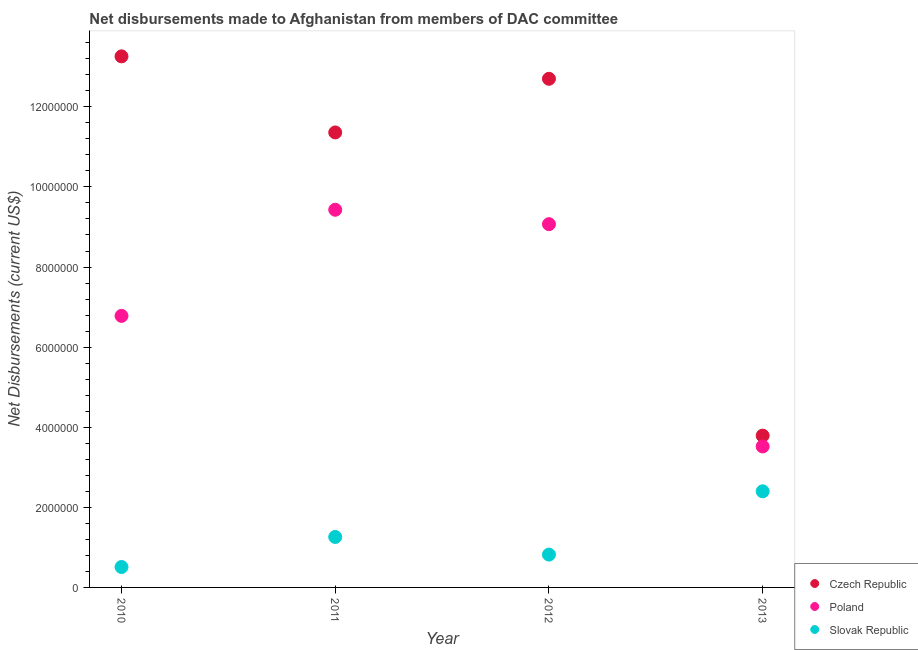What is the net disbursements made by slovak republic in 2012?
Your response must be concise. 8.20e+05. Across all years, what is the maximum net disbursements made by slovak republic?
Make the answer very short. 2.40e+06. Across all years, what is the minimum net disbursements made by czech republic?
Offer a terse response. 3.79e+06. In which year was the net disbursements made by czech republic maximum?
Provide a short and direct response. 2010. What is the total net disbursements made by czech republic in the graph?
Offer a very short reply. 4.11e+07. What is the difference between the net disbursements made by czech republic in 2010 and that in 2012?
Your response must be concise. 5.60e+05. What is the difference between the net disbursements made by poland in 2010 and the net disbursements made by czech republic in 2012?
Provide a succinct answer. -5.92e+06. What is the average net disbursements made by czech republic per year?
Your answer should be compact. 1.03e+07. In the year 2010, what is the difference between the net disbursements made by slovak republic and net disbursements made by czech republic?
Your answer should be very brief. -1.28e+07. What is the ratio of the net disbursements made by czech republic in 2012 to that in 2013?
Your answer should be very brief. 3.35. Is the difference between the net disbursements made by poland in 2010 and 2013 greater than the difference between the net disbursements made by slovak republic in 2010 and 2013?
Make the answer very short. Yes. What is the difference between the highest and the second highest net disbursements made by slovak republic?
Provide a succinct answer. 1.14e+06. What is the difference between the highest and the lowest net disbursements made by czech republic?
Your answer should be very brief. 9.47e+06. Is the net disbursements made by poland strictly less than the net disbursements made by slovak republic over the years?
Offer a very short reply. No. How many dotlines are there?
Make the answer very short. 3. How many years are there in the graph?
Offer a very short reply. 4. What is the difference between two consecutive major ticks on the Y-axis?
Give a very brief answer. 2.00e+06. Does the graph contain any zero values?
Give a very brief answer. No. Does the graph contain grids?
Make the answer very short. No. How many legend labels are there?
Make the answer very short. 3. What is the title of the graph?
Ensure brevity in your answer.  Net disbursements made to Afghanistan from members of DAC committee. Does "Interest" appear as one of the legend labels in the graph?
Keep it short and to the point. No. What is the label or title of the Y-axis?
Keep it short and to the point. Net Disbursements (current US$). What is the Net Disbursements (current US$) in Czech Republic in 2010?
Offer a terse response. 1.33e+07. What is the Net Disbursements (current US$) in Poland in 2010?
Offer a very short reply. 6.78e+06. What is the Net Disbursements (current US$) in Slovak Republic in 2010?
Your answer should be very brief. 5.10e+05. What is the Net Disbursements (current US$) in Czech Republic in 2011?
Provide a short and direct response. 1.14e+07. What is the Net Disbursements (current US$) in Poland in 2011?
Make the answer very short. 9.43e+06. What is the Net Disbursements (current US$) in Slovak Republic in 2011?
Keep it short and to the point. 1.26e+06. What is the Net Disbursements (current US$) in Czech Republic in 2012?
Your answer should be very brief. 1.27e+07. What is the Net Disbursements (current US$) of Poland in 2012?
Provide a short and direct response. 9.07e+06. What is the Net Disbursements (current US$) in Slovak Republic in 2012?
Your answer should be compact. 8.20e+05. What is the Net Disbursements (current US$) in Czech Republic in 2013?
Provide a short and direct response. 3.79e+06. What is the Net Disbursements (current US$) of Poland in 2013?
Offer a terse response. 3.52e+06. What is the Net Disbursements (current US$) in Slovak Republic in 2013?
Your response must be concise. 2.40e+06. Across all years, what is the maximum Net Disbursements (current US$) of Czech Republic?
Keep it short and to the point. 1.33e+07. Across all years, what is the maximum Net Disbursements (current US$) in Poland?
Ensure brevity in your answer.  9.43e+06. Across all years, what is the maximum Net Disbursements (current US$) of Slovak Republic?
Keep it short and to the point. 2.40e+06. Across all years, what is the minimum Net Disbursements (current US$) of Czech Republic?
Your response must be concise. 3.79e+06. Across all years, what is the minimum Net Disbursements (current US$) of Poland?
Offer a very short reply. 3.52e+06. Across all years, what is the minimum Net Disbursements (current US$) in Slovak Republic?
Ensure brevity in your answer.  5.10e+05. What is the total Net Disbursements (current US$) in Czech Republic in the graph?
Ensure brevity in your answer.  4.11e+07. What is the total Net Disbursements (current US$) in Poland in the graph?
Provide a succinct answer. 2.88e+07. What is the total Net Disbursements (current US$) in Slovak Republic in the graph?
Ensure brevity in your answer.  4.99e+06. What is the difference between the Net Disbursements (current US$) in Czech Republic in 2010 and that in 2011?
Give a very brief answer. 1.90e+06. What is the difference between the Net Disbursements (current US$) of Poland in 2010 and that in 2011?
Your answer should be compact. -2.65e+06. What is the difference between the Net Disbursements (current US$) in Slovak Republic in 2010 and that in 2011?
Offer a very short reply. -7.50e+05. What is the difference between the Net Disbursements (current US$) in Czech Republic in 2010 and that in 2012?
Keep it short and to the point. 5.60e+05. What is the difference between the Net Disbursements (current US$) in Poland in 2010 and that in 2012?
Keep it short and to the point. -2.29e+06. What is the difference between the Net Disbursements (current US$) of Slovak Republic in 2010 and that in 2012?
Provide a succinct answer. -3.10e+05. What is the difference between the Net Disbursements (current US$) of Czech Republic in 2010 and that in 2013?
Give a very brief answer. 9.47e+06. What is the difference between the Net Disbursements (current US$) of Poland in 2010 and that in 2013?
Your response must be concise. 3.26e+06. What is the difference between the Net Disbursements (current US$) of Slovak Republic in 2010 and that in 2013?
Your response must be concise. -1.89e+06. What is the difference between the Net Disbursements (current US$) in Czech Republic in 2011 and that in 2012?
Give a very brief answer. -1.34e+06. What is the difference between the Net Disbursements (current US$) in Slovak Republic in 2011 and that in 2012?
Offer a terse response. 4.40e+05. What is the difference between the Net Disbursements (current US$) of Czech Republic in 2011 and that in 2013?
Your answer should be very brief. 7.57e+06. What is the difference between the Net Disbursements (current US$) of Poland in 2011 and that in 2013?
Your answer should be very brief. 5.91e+06. What is the difference between the Net Disbursements (current US$) of Slovak Republic in 2011 and that in 2013?
Give a very brief answer. -1.14e+06. What is the difference between the Net Disbursements (current US$) of Czech Republic in 2012 and that in 2013?
Give a very brief answer. 8.91e+06. What is the difference between the Net Disbursements (current US$) in Poland in 2012 and that in 2013?
Your answer should be compact. 5.55e+06. What is the difference between the Net Disbursements (current US$) of Slovak Republic in 2012 and that in 2013?
Ensure brevity in your answer.  -1.58e+06. What is the difference between the Net Disbursements (current US$) in Czech Republic in 2010 and the Net Disbursements (current US$) in Poland in 2011?
Provide a short and direct response. 3.83e+06. What is the difference between the Net Disbursements (current US$) in Poland in 2010 and the Net Disbursements (current US$) in Slovak Republic in 2011?
Ensure brevity in your answer.  5.52e+06. What is the difference between the Net Disbursements (current US$) of Czech Republic in 2010 and the Net Disbursements (current US$) of Poland in 2012?
Provide a short and direct response. 4.19e+06. What is the difference between the Net Disbursements (current US$) in Czech Republic in 2010 and the Net Disbursements (current US$) in Slovak Republic in 2012?
Your response must be concise. 1.24e+07. What is the difference between the Net Disbursements (current US$) of Poland in 2010 and the Net Disbursements (current US$) of Slovak Republic in 2012?
Offer a very short reply. 5.96e+06. What is the difference between the Net Disbursements (current US$) in Czech Republic in 2010 and the Net Disbursements (current US$) in Poland in 2013?
Your answer should be very brief. 9.74e+06. What is the difference between the Net Disbursements (current US$) in Czech Republic in 2010 and the Net Disbursements (current US$) in Slovak Republic in 2013?
Offer a very short reply. 1.09e+07. What is the difference between the Net Disbursements (current US$) in Poland in 2010 and the Net Disbursements (current US$) in Slovak Republic in 2013?
Give a very brief answer. 4.38e+06. What is the difference between the Net Disbursements (current US$) in Czech Republic in 2011 and the Net Disbursements (current US$) in Poland in 2012?
Ensure brevity in your answer.  2.29e+06. What is the difference between the Net Disbursements (current US$) of Czech Republic in 2011 and the Net Disbursements (current US$) of Slovak Republic in 2012?
Offer a very short reply. 1.05e+07. What is the difference between the Net Disbursements (current US$) of Poland in 2011 and the Net Disbursements (current US$) of Slovak Republic in 2012?
Your answer should be compact. 8.61e+06. What is the difference between the Net Disbursements (current US$) of Czech Republic in 2011 and the Net Disbursements (current US$) of Poland in 2013?
Ensure brevity in your answer.  7.84e+06. What is the difference between the Net Disbursements (current US$) of Czech Republic in 2011 and the Net Disbursements (current US$) of Slovak Republic in 2013?
Offer a very short reply. 8.96e+06. What is the difference between the Net Disbursements (current US$) in Poland in 2011 and the Net Disbursements (current US$) in Slovak Republic in 2013?
Offer a very short reply. 7.03e+06. What is the difference between the Net Disbursements (current US$) in Czech Republic in 2012 and the Net Disbursements (current US$) in Poland in 2013?
Your answer should be very brief. 9.18e+06. What is the difference between the Net Disbursements (current US$) in Czech Republic in 2012 and the Net Disbursements (current US$) in Slovak Republic in 2013?
Keep it short and to the point. 1.03e+07. What is the difference between the Net Disbursements (current US$) of Poland in 2012 and the Net Disbursements (current US$) of Slovak Republic in 2013?
Give a very brief answer. 6.67e+06. What is the average Net Disbursements (current US$) in Czech Republic per year?
Keep it short and to the point. 1.03e+07. What is the average Net Disbursements (current US$) of Poland per year?
Make the answer very short. 7.20e+06. What is the average Net Disbursements (current US$) of Slovak Republic per year?
Give a very brief answer. 1.25e+06. In the year 2010, what is the difference between the Net Disbursements (current US$) in Czech Republic and Net Disbursements (current US$) in Poland?
Your response must be concise. 6.48e+06. In the year 2010, what is the difference between the Net Disbursements (current US$) of Czech Republic and Net Disbursements (current US$) of Slovak Republic?
Give a very brief answer. 1.28e+07. In the year 2010, what is the difference between the Net Disbursements (current US$) of Poland and Net Disbursements (current US$) of Slovak Republic?
Provide a succinct answer. 6.27e+06. In the year 2011, what is the difference between the Net Disbursements (current US$) in Czech Republic and Net Disbursements (current US$) in Poland?
Make the answer very short. 1.93e+06. In the year 2011, what is the difference between the Net Disbursements (current US$) in Czech Republic and Net Disbursements (current US$) in Slovak Republic?
Your answer should be very brief. 1.01e+07. In the year 2011, what is the difference between the Net Disbursements (current US$) in Poland and Net Disbursements (current US$) in Slovak Republic?
Your response must be concise. 8.17e+06. In the year 2012, what is the difference between the Net Disbursements (current US$) of Czech Republic and Net Disbursements (current US$) of Poland?
Your answer should be compact. 3.63e+06. In the year 2012, what is the difference between the Net Disbursements (current US$) of Czech Republic and Net Disbursements (current US$) of Slovak Republic?
Your response must be concise. 1.19e+07. In the year 2012, what is the difference between the Net Disbursements (current US$) in Poland and Net Disbursements (current US$) in Slovak Republic?
Keep it short and to the point. 8.25e+06. In the year 2013, what is the difference between the Net Disbursements (current US$) in Czech Republic and Net Disbursements (current US$) in Poland?
Provide a short and direct response. 2.70e+05. In the year 2013, what is the difference between the Net Disbursements (current US$) of Czech Republic and Net Disbursements (current US$) of Slovak Republic?
Provide a succinct answer. 1.39e+06. In the year 2013, what is the difference between the Net Disbursements (current US$) of Poland and Net Disbursements (current US$) of Slovak Republic?
Your answer should be very brief. 1.12e+06. What is the ratio of the Net Disbursements (current US$) of Czech Republic in 2010 to that in 2011?
Keep it short and to the point. 1.17. What is the ratio of the Net Disbursements (current US$) of Poland in 2010 to that in 2011?
Provide a succinct answer. 0.72. What is the ratio of the Net Disbursements (current US$) of Slovak Republic in 2010 to that in 2011?
Provide a short and direct response. 0.4. What is the ratio of the Net Disbursements (current US$) of Czech Republic in 2010 to that in 2012?
Provide a short and direct response. 1.04. What is the ratio of the Net Disbursements (current US$) of Poland in 2010 to that in 2012?
Provide a succinct answer. 0.75. What is the ratio of the Net Disbursements (current US$) in Slovak Republic in 2010 to that in 2012?
Your answer should be compact. 0.62. What is the ratio of the Net Disbursements (current US$) in Czech Republic in 2010 to that in 2013?
Give a very brief answer. 3.5. What is the ratio of the Net Disbursements (current US$) in Poland in 2010 to that in 2013?
Your answer should be very brief. 1.93. What is the ratio of the Net Disbursements (current US$) of Slovak Republic in 2010 to that in 2013?
Ensure brevity in your answer.  0.21. What is the ratio of the Net Disbursements (current US$) of Czech Republic in 2011 to that in 2012?
Keep it short and to the point. 0.89. What is the ratio of the Net Disbursements (current US$) of Poland in 2011 to that in 2012?
Make the answer very short. 1.04. What is the ratio of the Net Disbursements (current US$) of Slovak Republic in 2011 to that in 2012?
Make the answer very short. 1.54. What is the ratio of the Net Disbursements (current US$) in Czech Republic in 2011 to that in 2013?
Your response must be concise. 3. What is the ratio of the Net Disbursements (current US$) of Poland in 2011 to that in 2013?
Your answer should be compact. 2.68. What is the ratio of the Net Disbursements (current US$) of Slovak Republic in 2011 to that in 2013?
Keep it short and to the point. 0.53. What is the ratio of the Net Disbursements (current US$) of Czech Republic in 2012 to that in 2013?
Your response must be concise. 3.35. What is the ratio of the Net Disbursements (current US$) in Poland in 2012 to that in 2013?
Ensure brevity in your answer.  2.58. What is the ratio of the Net Disbursements (current US$) in Slovak Republic in 2012 to that in 2013?
Provide a short and direct response. 0.34. What is the difference between the highest and the second highest Net Disbursements (current US$) in Czech Republic?
Give a very brief answer. 5.60e+05. What is the difference between the highest and the second highest Net Disbursements (current US$) of Slovak Republic?
Provide a short and direct response. 1.14e+06. What is the difference between the highest and the lowest Net Disbursements (current US$) of Czech Republic?
Your answer should be compact. 9.47e+06. What is the difference between the highest and the lowest Net Disbursements (current US$) of Poland?
Provide a succinct answer. 5.91e+06. What is the difference between the highest and the lowest Net Disbursements (current US$) in Slovak Republic?
Your answer should be compact. 1.89e+06. 